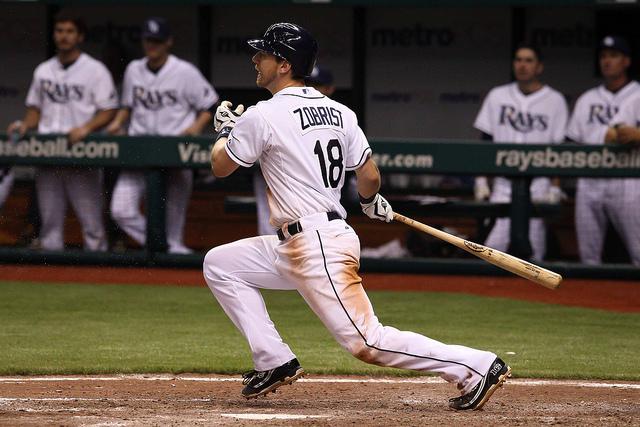Is his uniform clean?
Write a very short answer. No. Are these the same uniform?
Answer briefly. Yes. Is he holding the bat?
Write a very short answer. Yes. Has he already hit the ball?
Short answer required. Yes. 